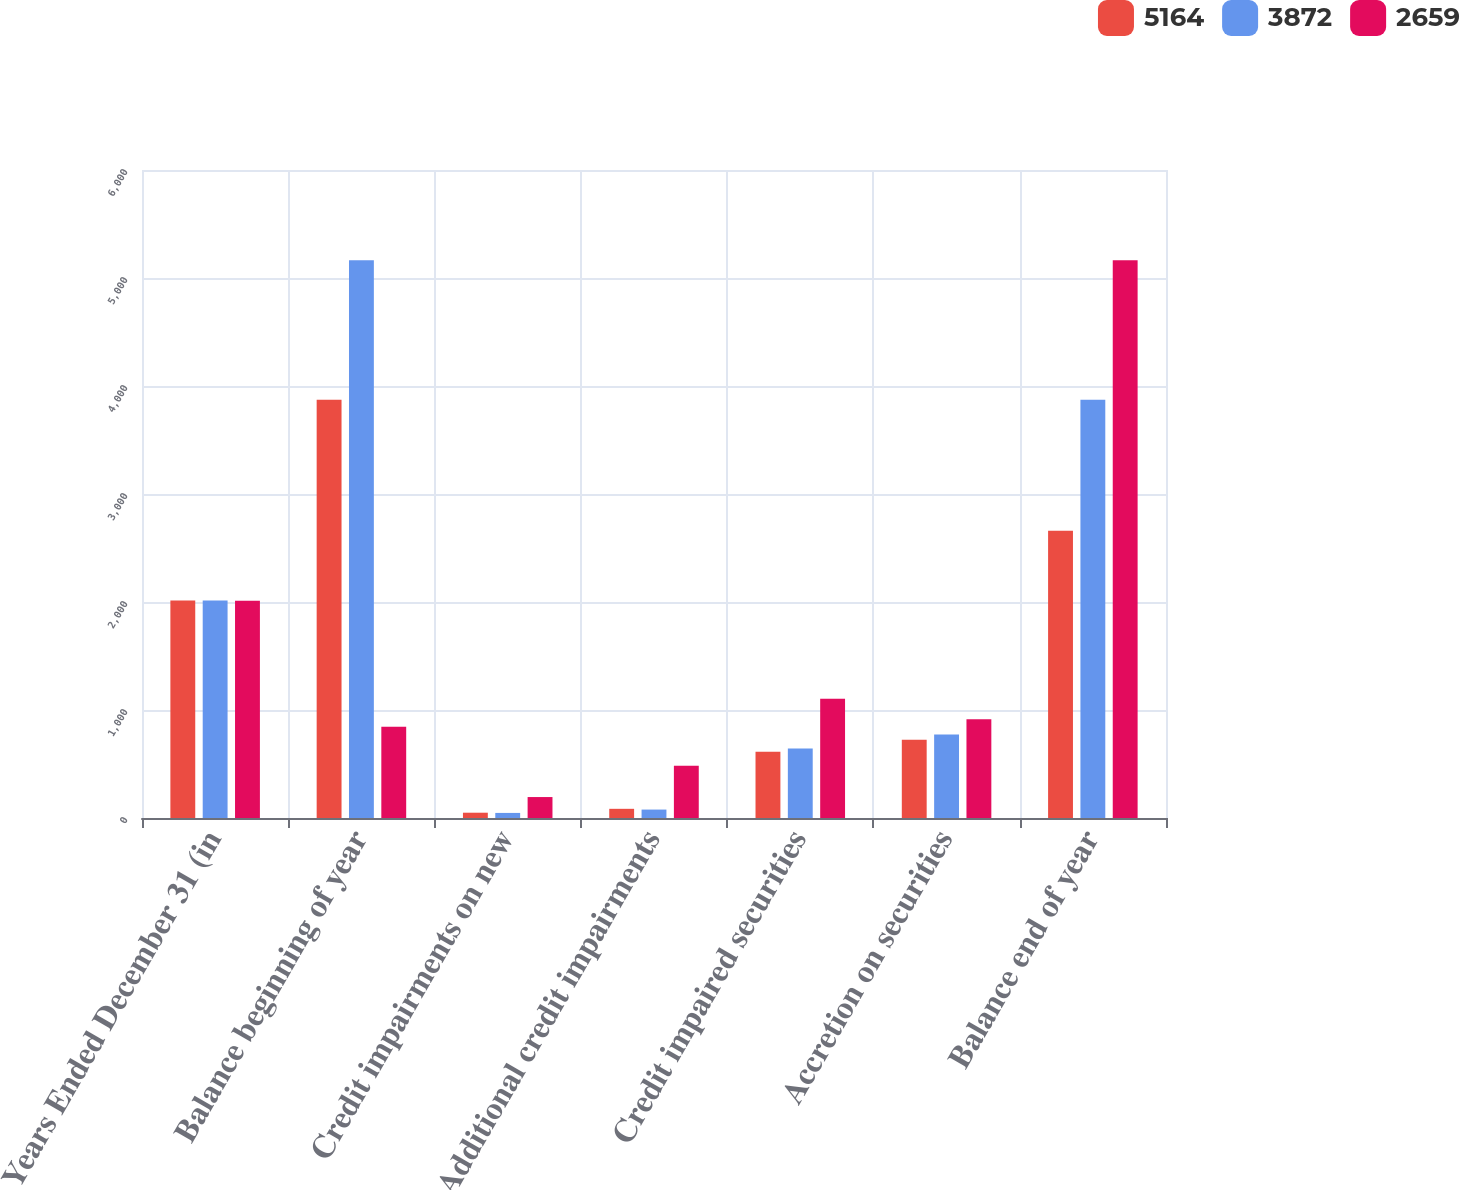Convert chart. <chart><loc_0><loc_0><loc_500><loc_500><stacked_bar_chart><ecel><fcel>Years Ended December 31 (in<fcel>Balance beginning of year<fcel>Credit impairments on new<fcel>Additional credit impairments<fcel>Credit impaired securities<fcel>Accretion on securities<fcel>Balance end of year<nl><fcel>5164<fcel>2014<fcel>3872<fcel>49<fcel>85<fcel>613<fcel>725<fcel>2659<nl><fcel>3872<fcel>2013<fcel>5164<fcel>47<fcel>78<fcel>643<fcel>774<fcel>3872<nl><fcel>2659<fcel>2012<fcel>844.5<fcel>194<fcel>483<fcel>1105<fcel>915<fcel>5164<nl></chart> 